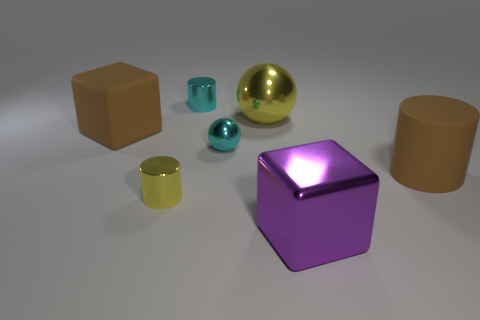Can you describe the colors of the objects in this image? Certainly! There is a rich variety of colors. The largest sphere in the center is a reflective yellow, there's a cyan smaller sphere, a metallic teal tinier sphere, and a large purple cube. Additionally, there are two matte blocks, one brown and one a warm tan color, as well as a cylindrical object that features a muted yellow tone.  How many objects are there in total in this scene? There are seven objects in total: one large yellow reflective sphere, one purple cube, one cyan smaller sphere, one metallic teal tiny sphere, two matte blocks in brown and tan, and one muted yellow cylinder. 